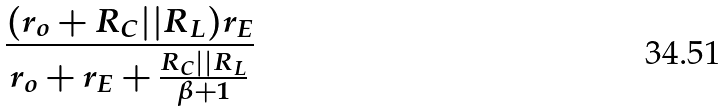Convert formula to latex. <formula><loc_0><loc_0><loc_500><loc_500>\frac { ( r _ { o } + R _ { C } | | R _ { L } ) r _ { E } } { r _ { o } + r _ { E } + \frac { R _ { C } | | R _ { L } } { \beta + 1 } }</formula> 